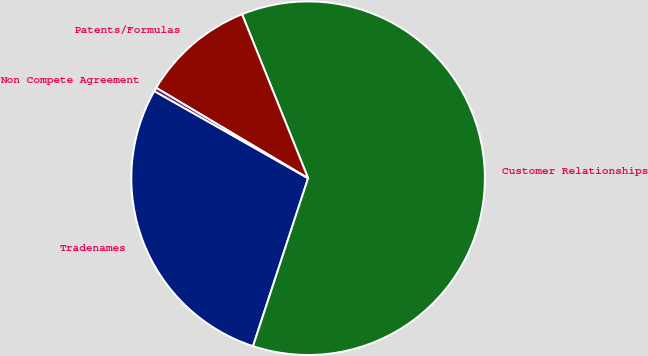Convert chart. <chart><loc_0><loc_0><loc_500><loc_500><pie_chart><fcel>Tradenames<fcel>Customer Relationships<fcel>Patents/Formulas<fcel>Non Compete Agreement<nl><fcel>28.16%<fcel>61.14%<fcel>10.36%<fcel>0.34%<nl></chart> 